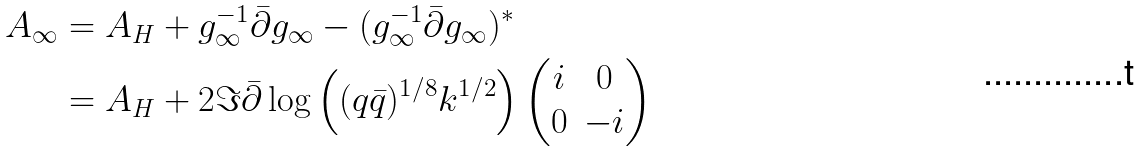Convert formula to latex. <formula><loc_0><loc_0><loc_500><loc_500>A _ { \infty } & = A _ { H } + g _ { \infty } ^ { - 1 } \bar { \partial } g _ { \infty } - ( g _ { \infty } ^ { - 1 } \bar { \partial } g _ { \infty } ) ^ { * } \\ & = A _ { H } + 2 \Im \bar { \partial } \log \left ( ( q \bar { q } ) ^ { 1 / 8 } k ^ { 1 / 2 } \right ) \begin{pmatrix} i & 0 \\ 0 & - i \end{pmatrix}</formula> 